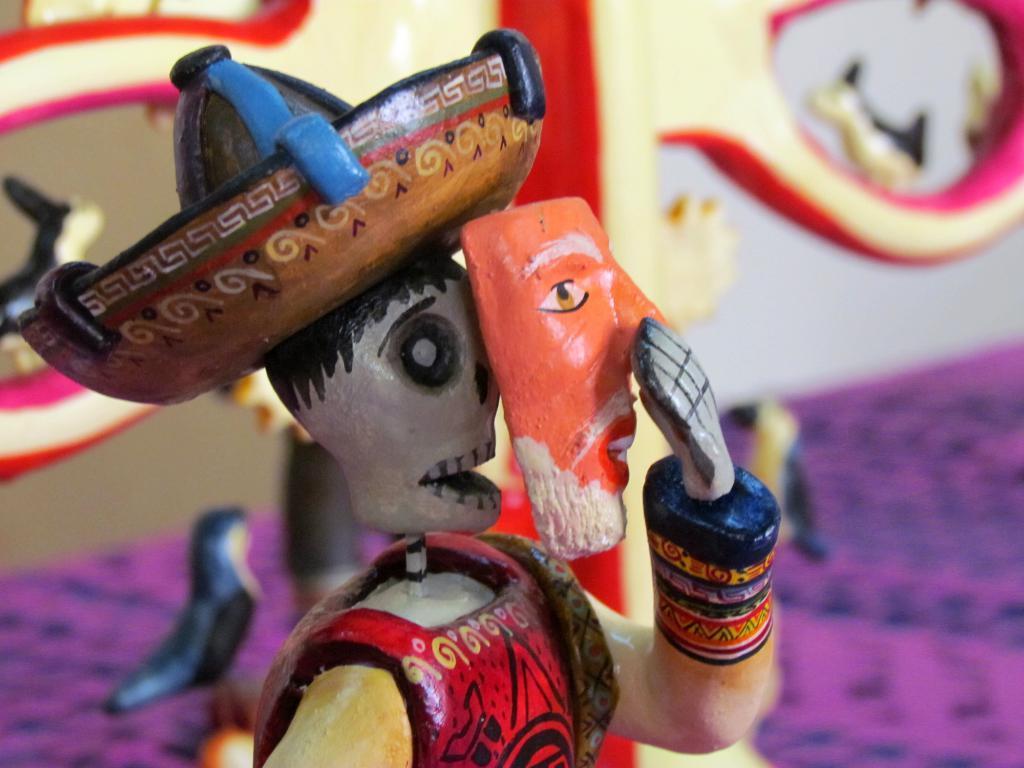Please provide a concise description of this image. In this picture we can see toys. In the background of the image it is blurry. 